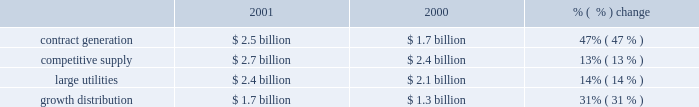Future impairments would be recorded in income from continuing operations .
The statement provides specific guidance for testing goodwill for impairment .
The company had $ 3.2 billion of goodwill at december 31 , 2001 .
Goodwill amortization was $ 62 million for the year ended december 31 , 2001 .
The company is currently assessing the impact of sfas no .
142 on its financial position and results of operations .
In june 2001 , the fasb issued sfas no .
143 , 2018 2018accounting for asset retirement obligations , 2019 2019 which addresses financial accounting and reporting for obligations associated with the retirement of tangible long-lived assets and the associated asset retirement costs .
This statement is effective for financial statements issued for fiscal years beginning after june 15 , 2002 .
The statement requires recognition of legal obligations associated with the retirement of a long-lived asset , except for certain obligations of lessees .
The company is currently assessing the impact of sfas no .
143 on its financial position and results of operations .
In december 2001 , the fasb revised its earlier conclusion , derivatives implementation group ( 2018 2018dig 2019 2019 ) issue c-15 , related to contracts involving the purchase or sale of electricity .
Contracts for the purchase or sale of electricity , both forward and option contracts , including capacity contracts , may qualify for the normal purchases and sales exemption and are not required to be accounted for as derivatives under sfas no .
133 .
In order for contracts to qualify for this exemption , they must meet certain criteria , which include the requirement for physical delivery of the electricity to be purchased or sold under the contract only in the normal course of business .
Additionally , contracts that have a price based on an underlying that is not clearly and closely related to the electricity being sold or purchased or that are denominated in a currency that is foreign to the buyer or seller are not considered normal purchases and normal sales and are required to be accounted for as derivatives under sfas no .
133 .
This revised conclusion is effective beginning april 1 , 2002 .
The company is currently assessing the impact of revised dig issue c-15 on its financial condition and results of operations .
2001 compared to 2000 revenues revenues increased $ 1.8 billion , or 24% ( 24 % ) to $ 9.3 billion in 2001 from $ 7.5 billion in 2000 .
The increase in revenues is due to the acquisition of new businesses , new operations from greenfield projects and positive improvements from existing operations .
Excluding businesses acquired or that commenced commercial operations in 2001 or 2000 , revenues increased 5% ( 5 % ) to $ 7.1 billion in 2001 .
The table shows the revenue of each segment: .
Contract generation revenues increased $ 800 million , or 47% ( 47 % ) to $ 2.5 billion in 2001 from $ 1.7 billion in 2000 , principally resulting from the addition of revenues attributable to businesses acquired during 2001 or 2000 .
Excluding businesses acquired or that commenced commercial operations in 2001 or 2000 , contract generation revenues increased 2% ( 2 % ) to $ 1.7 billion in 2001 .
The increase in contract generation segment revenues was due primarily to increases in south america , europe/africa and asia .
In south america , contract generation segment revenues increased $ 472 million due mainly to the acquisition of gener and the full year of operations at uruguaiana offset by reduced revenues at tiete from the electricity rationing in brazil .
In europe/africa , contract generation segment revenues increased $ 88 million , and the acquisition of a controlling interest in kilroot during 2000 was the largest contributor to the increase .
In asia , contract generation segment revenues increased $ 96 million , and increased operations from our ecogen peaking plant was the most significant contributor to the .
What were 2001 total segment revenues in billions? 
Computations: (1.7 + ((2.5 + 2.7) + 2.4))
Answer: 9.3. 